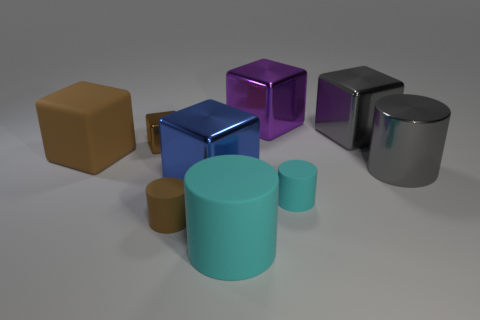How many large cubes are made of the same material as the blue object?
Offer a very short reply. 2. What is the size of the brown matte thing in front of the tiny matte object on the right side of the big cyan cylinder?
Your answer should be very brief. Small. There is a big metallic block that is in front of the purple metallic cube and to the left of the tiny cyan object; what is its color?
Your answer should be very brief. Blue. Is the shape of the large cyan rubber object the same as the large brown matte object?
Keep it short and to the point. No. What is the size of the cylinder that is the same color as the small block?
Your answer should be very brief. Small. The tiny brown object behind the big cylinder that is to the right of the large matte cylinder is what shape?
Your answer should be compact. Cube. Does the tiny brown rubber thing have the same shape as the large thing on the left side of the tiny cube?
Provide a succinct answer. No. There is another rubber cube that is the same size as the blue cube; what is its color?
Offer a terse response. Brown. Is the number of cyan cylinders that are left of the large rubber cylinder less than the number of large blue objects that are in front of the big blue block?
Provide a short and direct response. No. What is the shape of the cyan matte object that is behind the large cylinder that is in front of the brown matte object in front of the brown matte block?
Offer a terse response. Cylinder. 